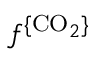<formula> <loc_0><loc_0><loc_500><loc_500>f ^ { \{ { C O _ { 2 } } \} }</formula> 